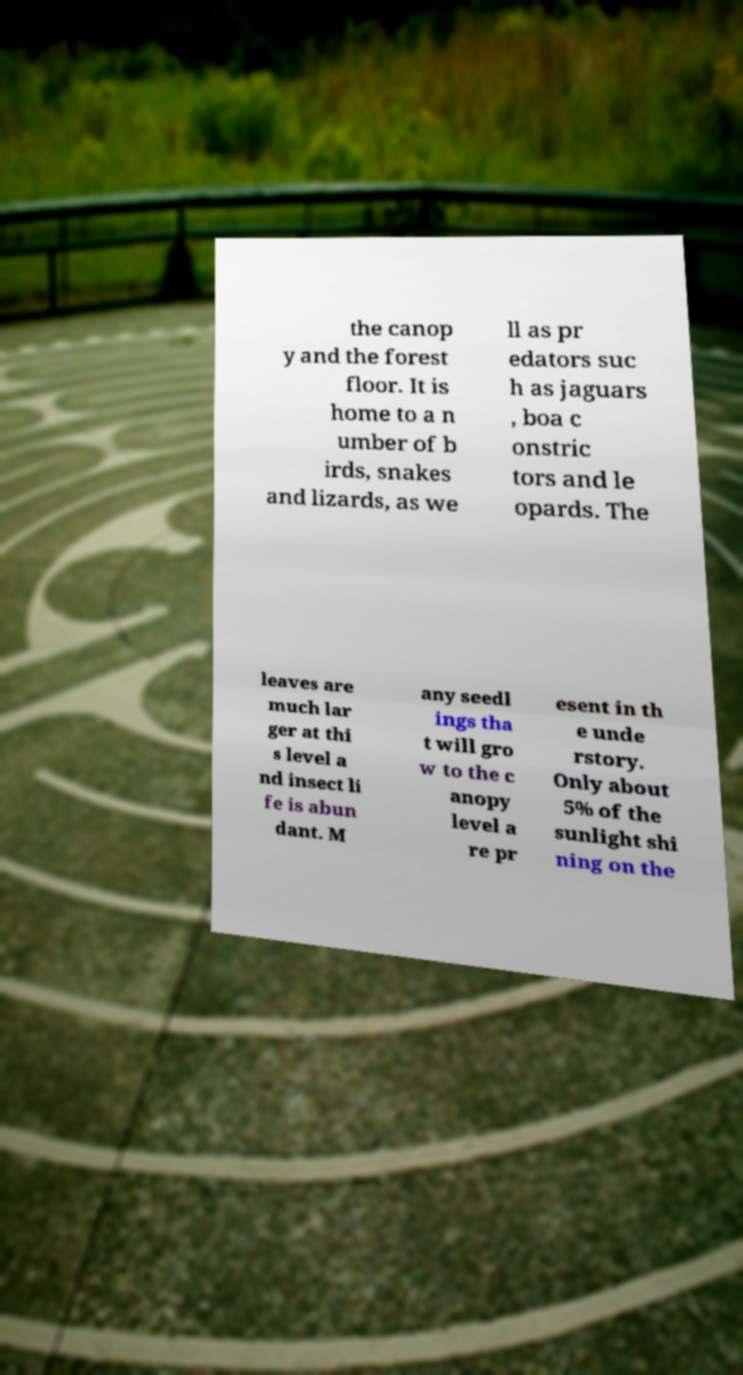For documentation purposes, I need the text within this image transcribed. Could you provide that? the canop y and the forest floor. It is home to a n umber of b irds, snakes and lizards, as we ll as pr edators suc h as jaguars , boa c onstric tors and le opards. The leaves are much lar ger at thi s level a nd insect li fe is abun dant. M any seedl ings tha t will gro w to the c anopy level a re pr esent in th e unde rstory. Only about 5% of the sunlight shi ning on the 